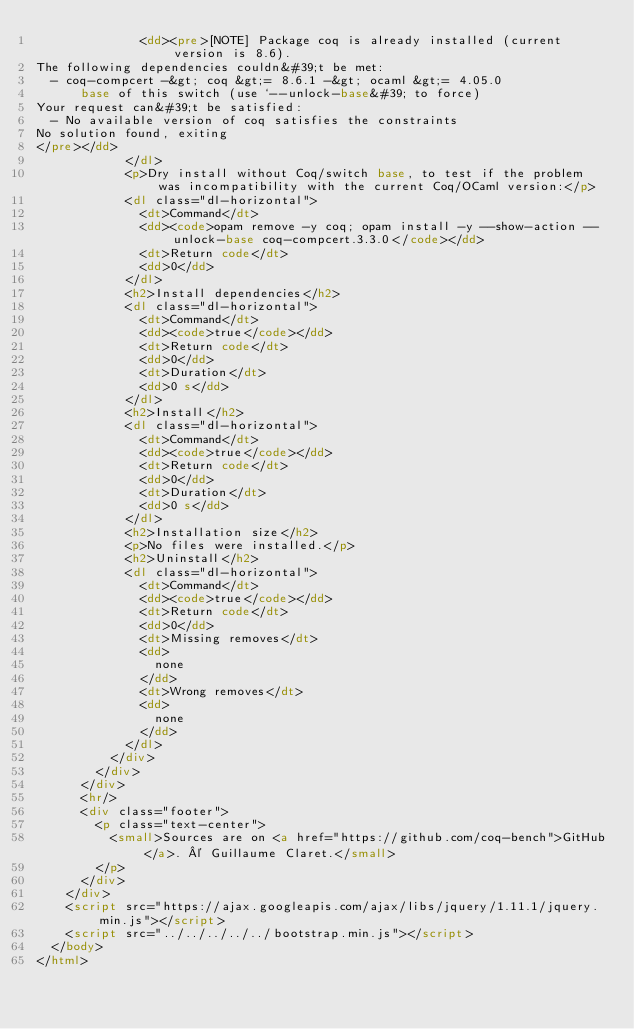Convert code to text. <code><loc_0><loc_0><loc_500><loc_500><_HTML_>              <dd><pre>[NOTE] Package coq is already installed (current version is 8.6).
The following dependencies couldn&#39;t be met:
  - coq-compcert -&gt; coq &gt;= 8.6.1 -&gt; ocaml &gt;= 4.05.0
      base of this switch (use `--unlock-base&#39; to force)
Your request can&#39;t be satisfied:
  - No available version of coq satisfies the constraints
No solution found, exiting
</pre></dd>
            </dl>
            <p>Dry install without Coq/switch base, to test if the problem was incompatibility with the current Coq/OCaml version:</p>
            <dl class="dl-horizontal">
              <dt>Command</dt>
              <dd><code>opam remove -y coq; opam install -y --show-action --unlock-base coq-compcert.3.3.0</code></dd>
              <dt>Return code</dt>
              <dd>0</dd>
            </dl>
            <h2>Install dependencies</h2>
            <dl class="dl-horizontal">
              <dt>Command</dt>
              <dd><code>true</code></dd>
              <dt>Return code</dt>
              <dd>0</dd>
              <dt>Duration</dt>
              <dd>0 s</dd>
            </dl>
            <h2>Install</h2>
            <dl class="dl-horizontal">
              <dt>Command</dt>
              <dd><code>true</code></dd>
              <dt>Return code</dt>
              <dd>0</dd>
              <dt>Duration</dt>
              <dd>0 s</dd>
            </dl>
            <h2>Installation size</h2>
            <p>No files were installed.</p>
            <h2>Uninstall</h2>
            <dl class="dl-horizontal">
              <dt>Command</dt>
              <dd><code>true</code></dd>
              <dt>Return code</dt>
              <dd>0</dd>
              <dt>Missing removes</dt>
              <dd>
                none
              </dd>
              <dt>Wrong removes</dt>
              <dd>
                none
              </dd>
            </dl>
          </div>
        </div>
      </div>
      <hr/>
      <div class="footer">
        <p class="text-center">
          <small>Sources are on <a href="https://github.com/coq-bench">GitHub</a>. © Guillaume Claret.</small>
        </p>
      </div>
    </div>
    <script src="https://ajax.googleapis.com/ajax/libs/jquery/1.11.1/jquery.min.js"></script>
    <script src="../../../../../bootstrap.min.js"></script>
  </body>
</html>
</code> 